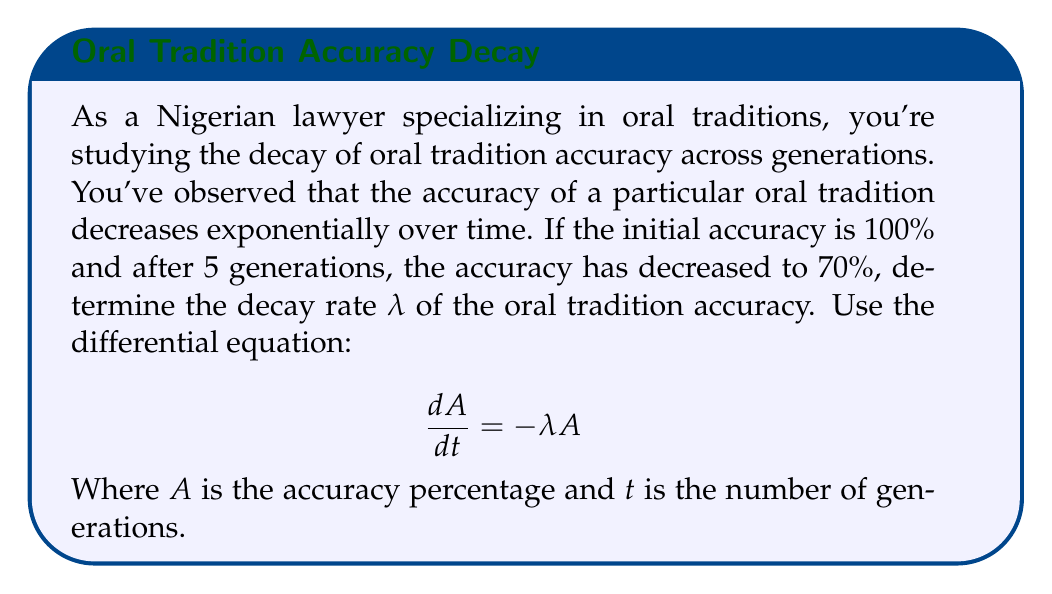Provide a solution to this math problem. To solve this problem, we'll follow these steps:

1) The general solution to the differential equation $\frac{dA}{dt} = -λA$ is:
   
   $$A(t) = A_0e^{-λt}$$

   Where $A_0$ is the initial accuracy (100% in this case).

2) We know two points: 
   At t = 0, A = 100%
   At t = 5, A = 70%

3) Let's substitute these into our equation:

   $$70 = 100e^{-5λ}$$

4) Divide both sides by 100:

   $$0.7 = e^{-5λ}$$

5) Take the natural log of both sides:

   $$\ln(0.7) = -5λ$$

6) Solve for λ:

   $$λ = -\frac{\ln(0.7)}{5}$$

7) Calculate the value:

   $$λ ≈ 0.0713$$

This means the accuracy decays at a rate of about 7.13% per generation.
Answer: $λ ≈ 0.0713$ per generation 